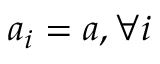<formula> <loc_0><loc_0><loc_500><loc_500>a _ { i } = a , \forall i</formula> 